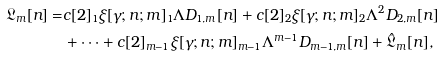<formula> <loc_0><loc_0><loc_500><loc_500>\mathfrak { L } _ { m } [ n ] = & c [ 2 ] _ { 1 } \xi [ \gamma ; n ; m ] _ { 1 } \Lambda D _ { 1 , m } [ n ] + c [ 2 ] _ { 2 } \xi [ \gamma ; n ; m ] _ { 2 } \Lambda ^ { 2 } D _ { 2 , m } [ n ] \\ & + \dots + c [ 2 ] _ { m - 1 } \xi [ \gamma ; n ; m ] _ { m - 1 } \Lambda ^ { m - 1 } D _ { m - 1 , m } [ n ] + \hat { \mathfrak { L } } _ { m } [ n ] ,</formula> 